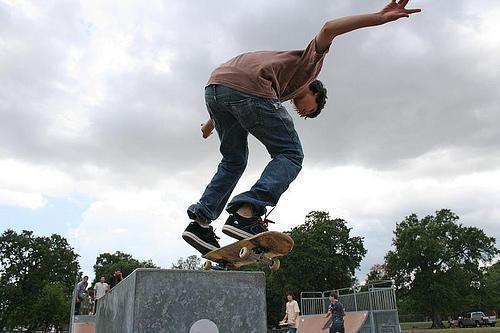What is the best material for a skateboard?
From the following four choices, select the correct answer to address the question.
Options: Maple, pine, palm, coconut. Maple. 